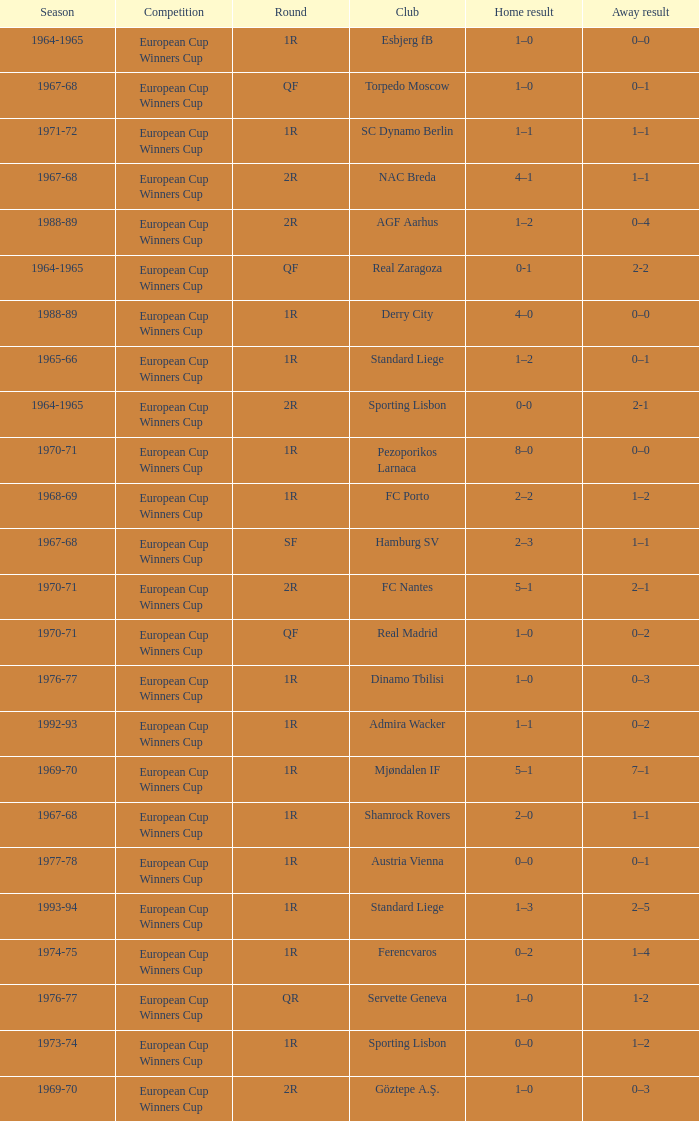Away result of 0–3, and a Season of 1969-70 is what competition? European Cup Winners Cup. 